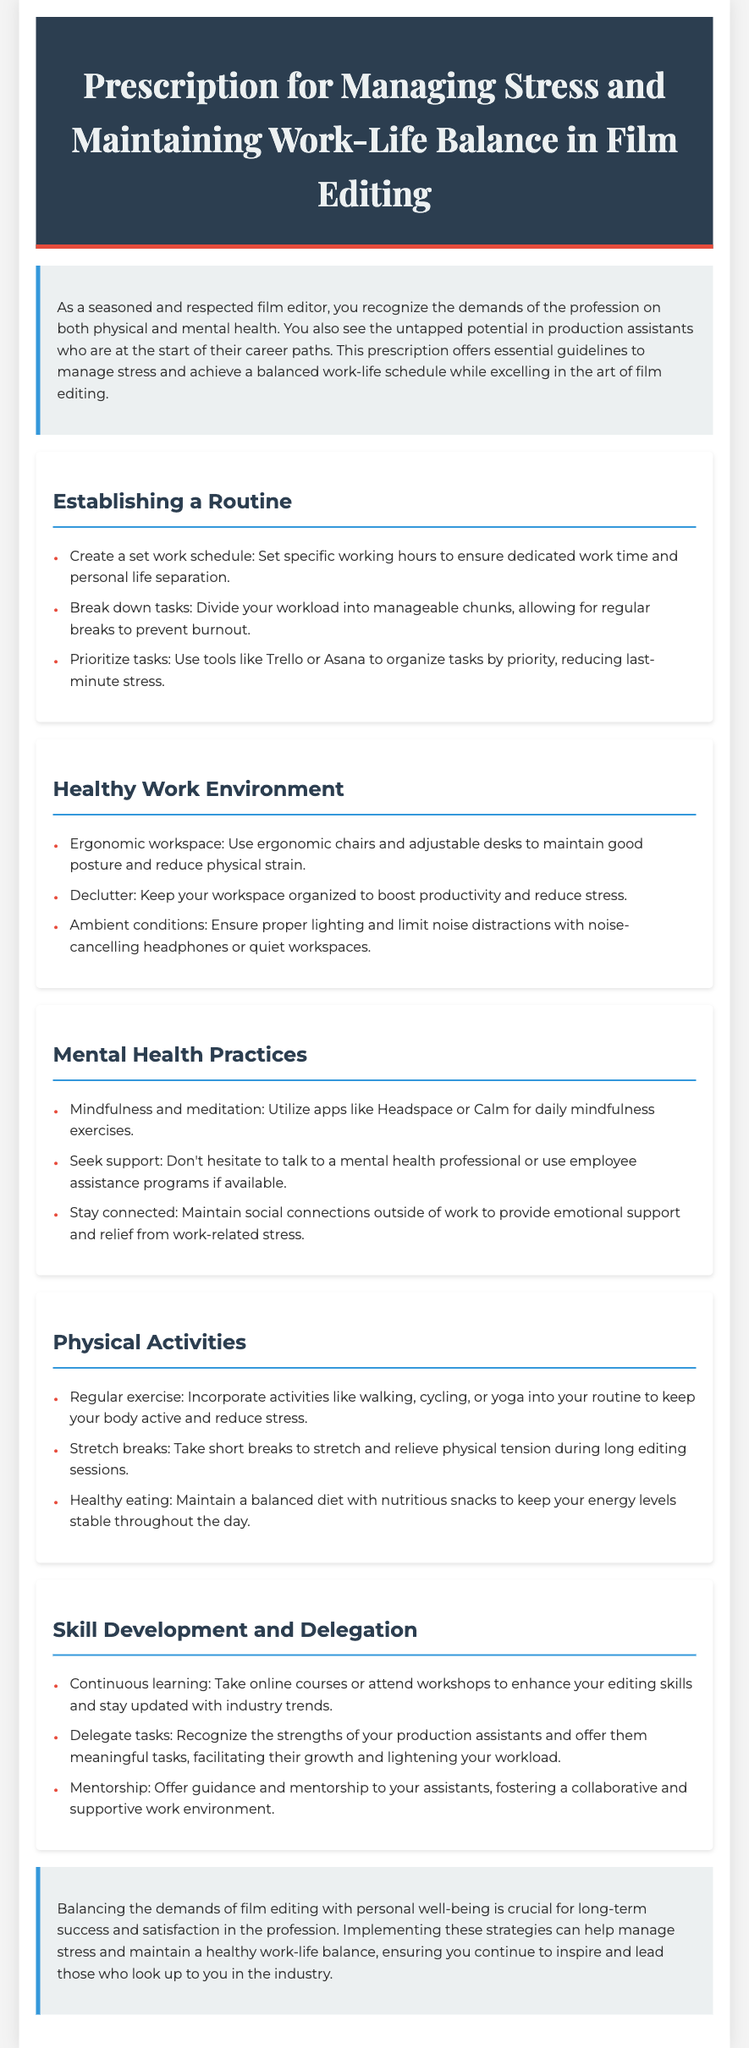What is the title of the document? The title of the document is prominently displayed in the header section.
Answer: Prescription for Managing Stress and Maintaining Work-Life Balance in Film Editing How many sections are in the document? The document contains several sections, each providing guidelines for managing stress and work-life balance.
Answer: Five What tool can be used to organize tasks by priority? The document suggests using specific tools for task organization, including one mentioned explicitly.
Answer: Trello What is suggested for maintaining good posture? The document recommends specific furniture or equipment to promote physical health while working.
Answer: Ergonomic chairs Which two apps are recommended for mindfulness exercises? The document lists two specific applications that can assist with mindfulness practices.
Answer: Headspace, Calm What is one activity mentioned to reduce stress? The document suggests a specific physical activity to help alleviate stress.
Answer: Yoga Who should you seek support from if feeling overwhelmed? The document mentions a group of professionals that can provide help when needed.
Answer: Mental health professional What is a recommended strategy for skill development? The document encourages a specific approach to enhance professional skills.
Answer: Continuous learning What should you maintain outside of work for emotional support? The document emphasizes the importance of certain relationships for personal well-being.
Answer: Social connections 